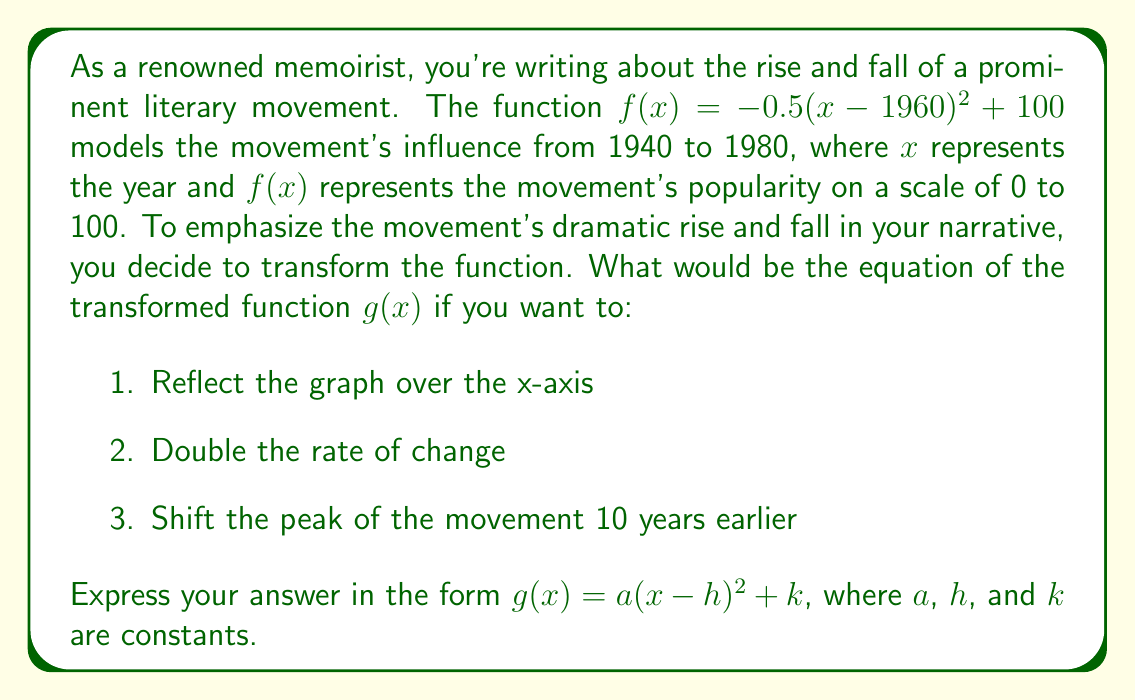Could you help me with this problem? Let's approach this step-by-step:

1. The original function is $f(x) = -0.5(x-1960)^2 + 100$

2. To reflect over the x-axis, we multiply the function by -1:
   $-f(x) = 0.5(x-1960)^2 - 100$

3. To double the rate of change, we multiply the coefficient of $(x-1960)^2$ by 2:
   $g(x) = 2[0.5(x-1960)^2] - 100 = (x-1960)^2 - 100$

4. To shift the peak 10 years earlier, we replace $(x-1960)$ with $(x-1950)$:
   $g(x) = (x-1950)^2 - 100$

5. Now we have the function in the form $g(x) = a(x-h)^2 + k$, where:
   $a = 1$ (the coefficient of the quadratic term)
   $h = 1950$ (the horizontal shift)
   $k = -100$ (the vertical shift)

Therefore, the final transformed function is:

$g(x) = (x-1950)^2 - 100$

This function reflects the original over the x-axis, doubles its rate of change, and shifts its peak 10 years earlier, providing a more dramatic narrative arc for your memoir.
Answer: $g(x) = (x-1950)^2 - 100$ 